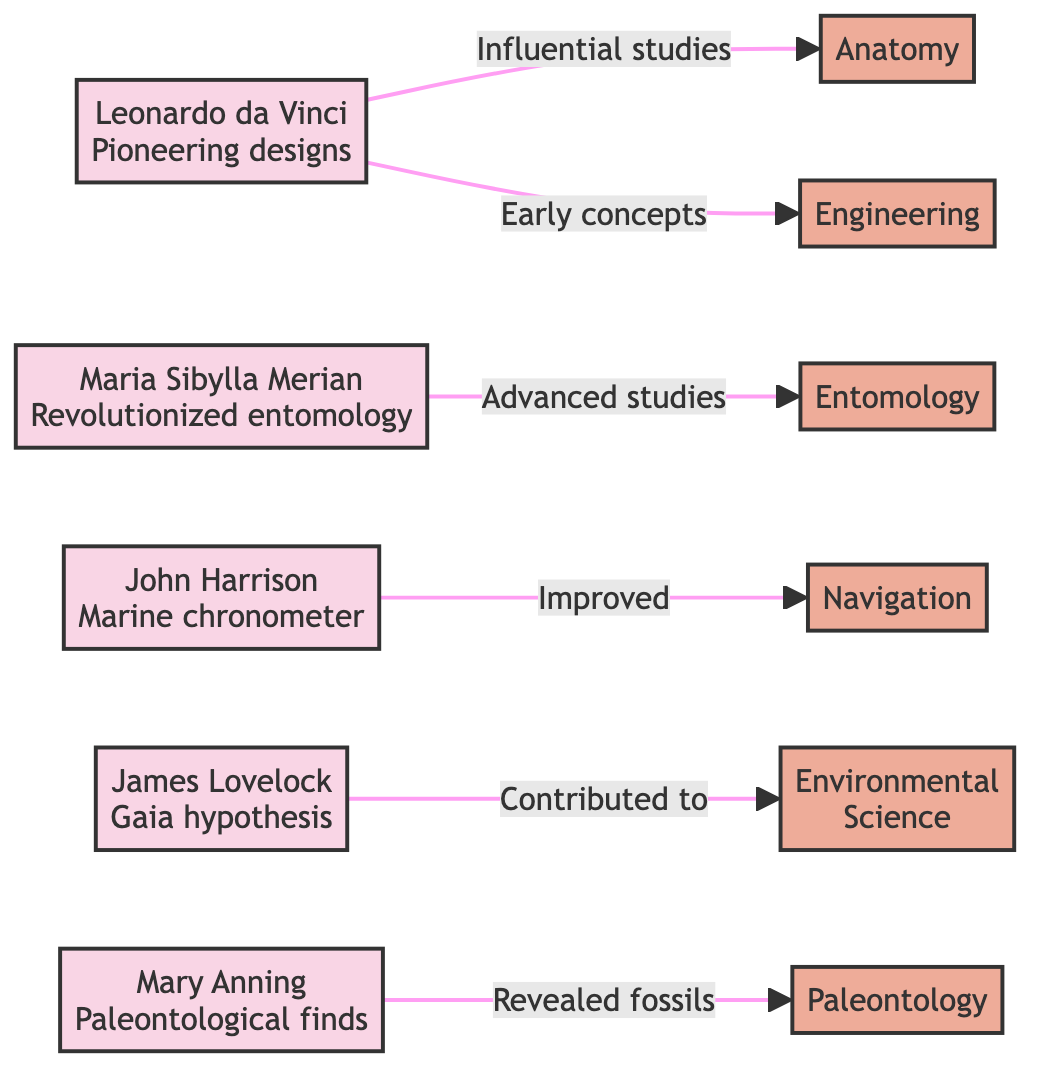What is the primary field associated with Leonardo da Vinci? The diagram shows "Anatomy" and "Engineering" as fields associated with Leonardo da Vinci, but "Anatomy" is listed first. Therefore, the primary field connected by the arrow from Leonardo da Vinci is "Anatomy."
Answer: Anatomy How many scientists are featured in the diagram? By counting the individual scientist nodes in the diagram, there are five distinct scientists represented: Leonardo da Vinci, Maria Sibylla Merian, John Harrison, James Lovelock, and Mary Anning. Thus, the total number of scientists is five.
Answer: 5 Which scientist is linked to the field of navigation? The diagram indicates that John Harrison is connected to the field of navigation via an arrow labeled "Improved." This establishes he as the scientist associated with navigation.
Answer: John Harrison What lesser-known contributor is associated with paleontology? According to the diagram, Mary Anning is linked to paleontology through an arrow labeled "Revealed fossils." Therefore, Mary Anning is the lesser-known contributor associated with paleontology.
Answer: Mary Anning Which two scientists contributed to different fields in the diagram? The diagram highlights several distinct connections; for example, Maria Sibylla Merian contributes to entomology, and James Lovelock contributes to environmental science. This establishes an example of two scientists (Maria Sibylla Merian and James Lovelock) contributing to different fields.
Answer: Maria Sibylla Merian and James Lovelock 